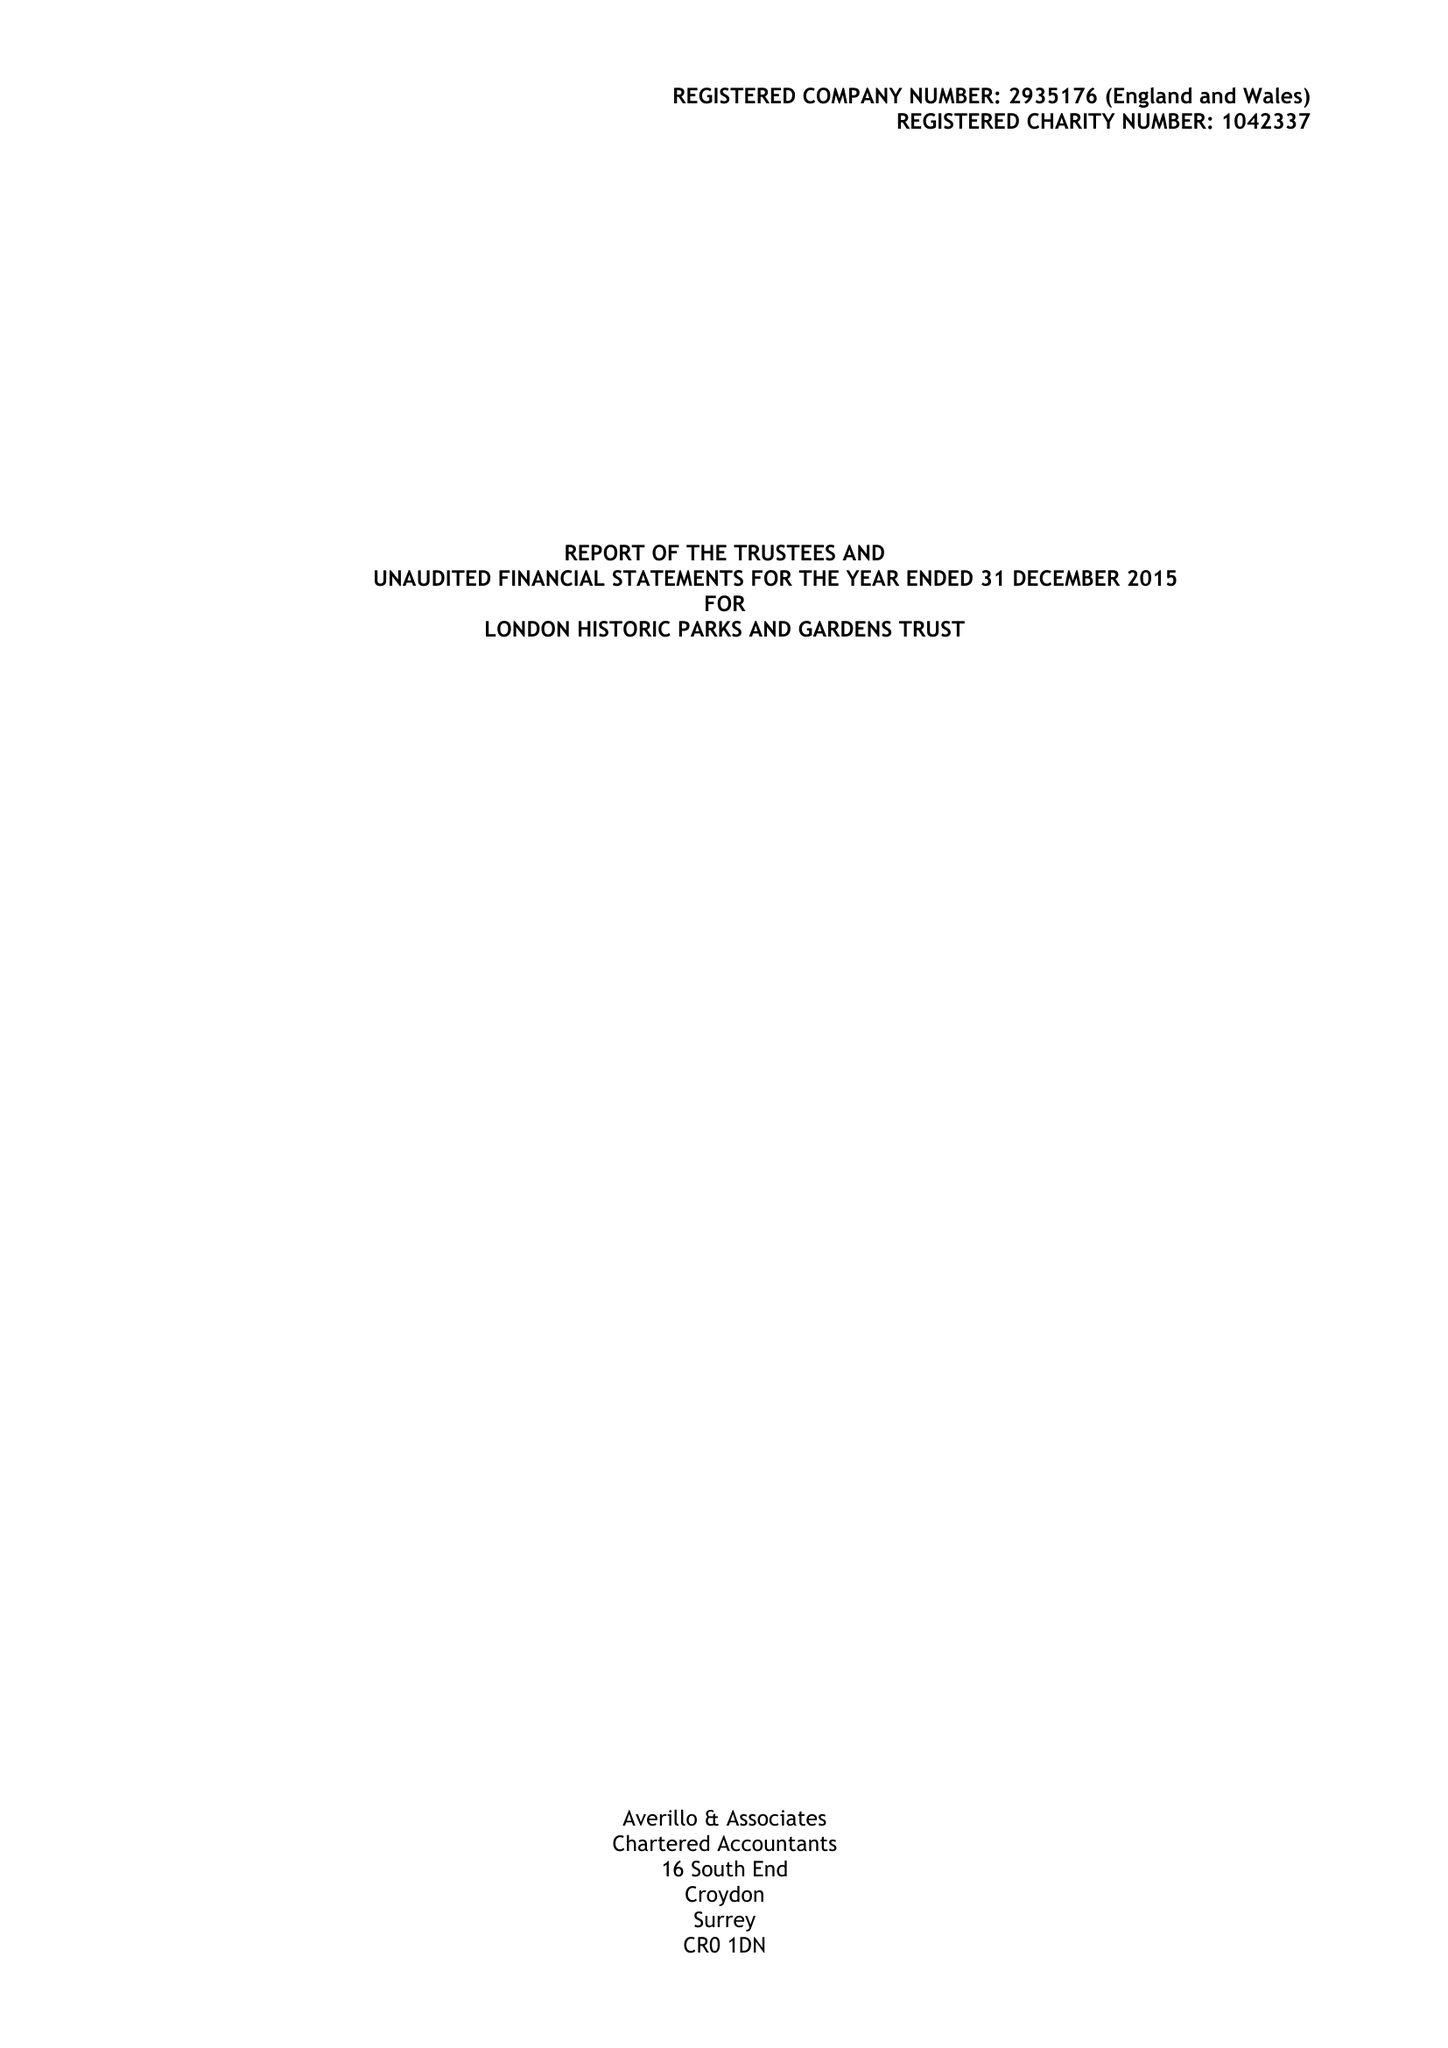What is the value for the income_annually_in_british_pounds?
Answer the question using a single word or phrase. 156291.00 